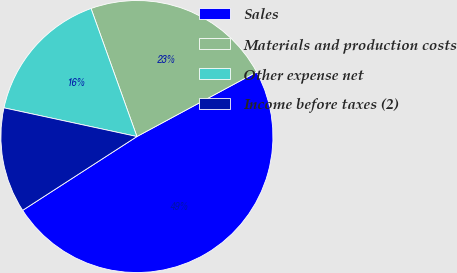<chart> <loc_0><loc_0><loc_500><loc_500><pie_chart><fcel>Sales<fcel>Materials and production costs<fcel>Other expense net<fcel>Income before taxes (2)<nl><fcel>48.74%<fcel>22.61%<fcel>16.14%<fcel>12.51%<nl></chart> 